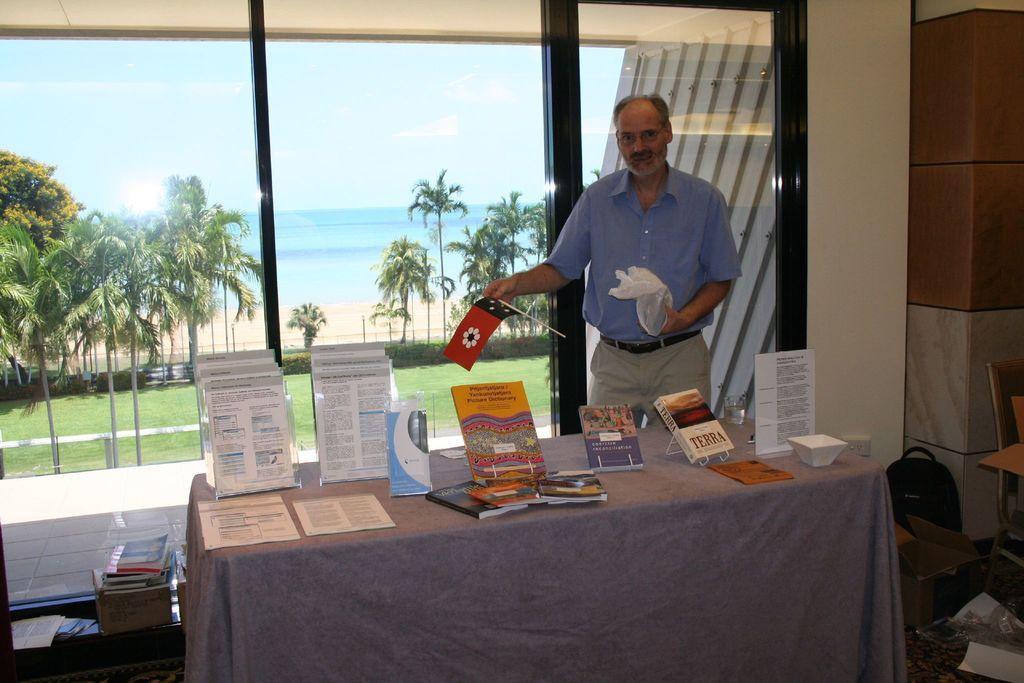Could you give a brief overview of what you see in this image? In this image in the center there is a table covered with a cloth. On the table there are papers and there is a man standing and holding a flag and white colour object in his hand. In the background there is window, behind the window there's grass on the ground and there are trees and there is water. On the right side there is bag on the floor and there are papers and there is an empty chair. On the left side there is a stool which is black in colour. On the stool there are objects. 